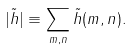<formula> <loc_0><loc_0><loc_500><loc_500>| \tilde { h } | \equiv \sum _ { m , n } \tilde { h } ( m , n ) .</formula> 